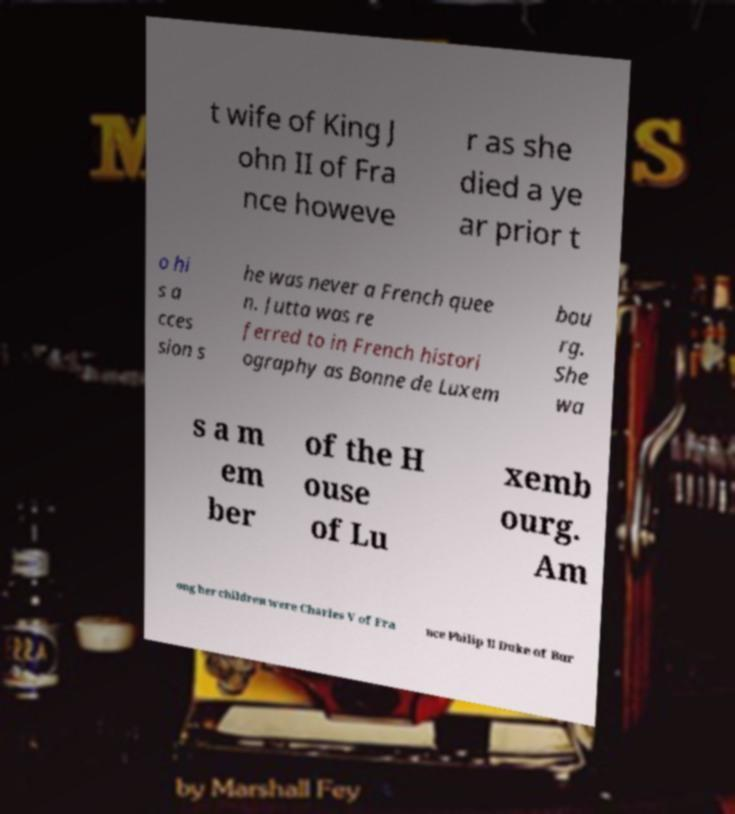Please read and relay the text visible in this image. What does it say? t wife of King J ohn II of Fra nce howeve r as she died a ye ar prior t o hi s a cces sion s he was never a French quee n. Jutta was re ferred to in French histori ography as Bonne de Luxem bou rg. She wa s a m em ber of the H ouse of Lu xemb ourg. Am ong her children were Charles V of Fra nce Philip II Duke of Bur 